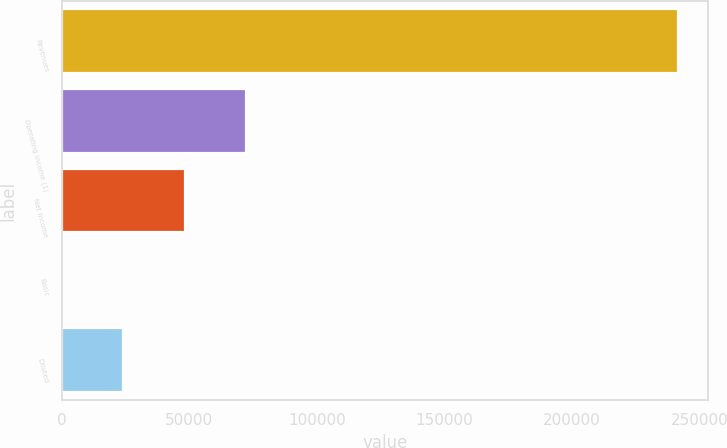Convert chart. <chart><loc_0><loc_0><loc_500><loc_500><bar_chart><fcel>Revenues<fcel>Operating income (1)<fcel>Net income<fcel>Basic<fcel>Diluted<nl><fcel>241360<fcel>72408.1<fcel>48272.1<fcel>0.08<fcel>24136.1<nl></chart> 